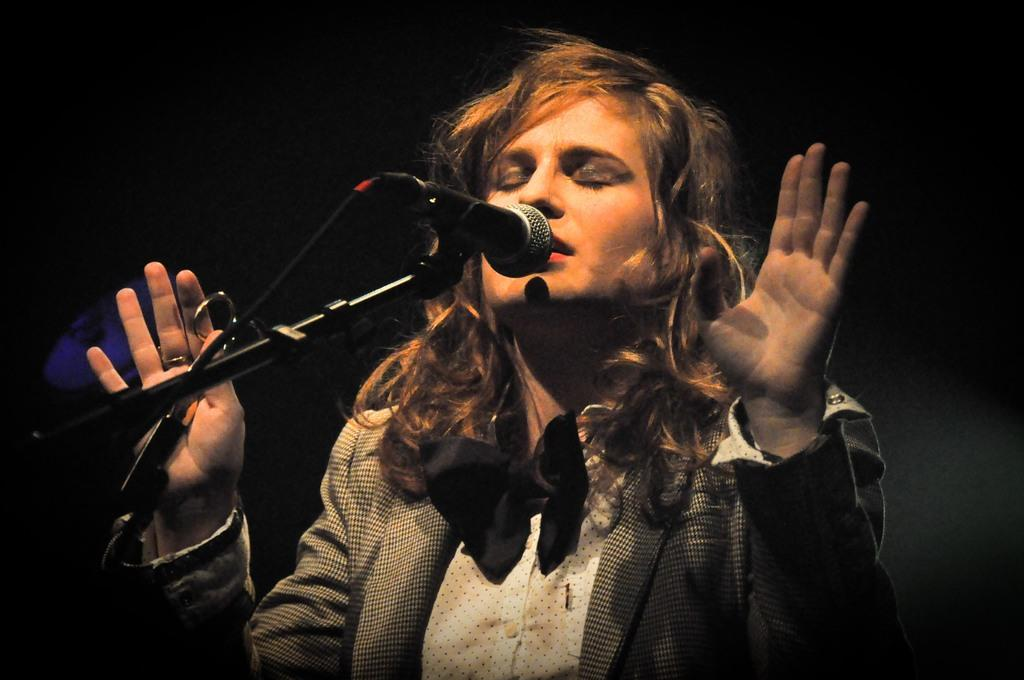Who is the main subject in the image? There is a woman in the center of the image. What is the woman doing in the image? The woman is singing in the image. What is the woman holding in front of her? There is a microphone in front of the woman. What color is the background of the image? The background of the image is black. What type of station is the woman working at in the image? There is no station present in the image; it features a woman singing with a microphone in front of her. What kind of drug is the woman administering to the audience in the image? There is no drug present in the image, and the woman is singing, not administering anything to the audience. 